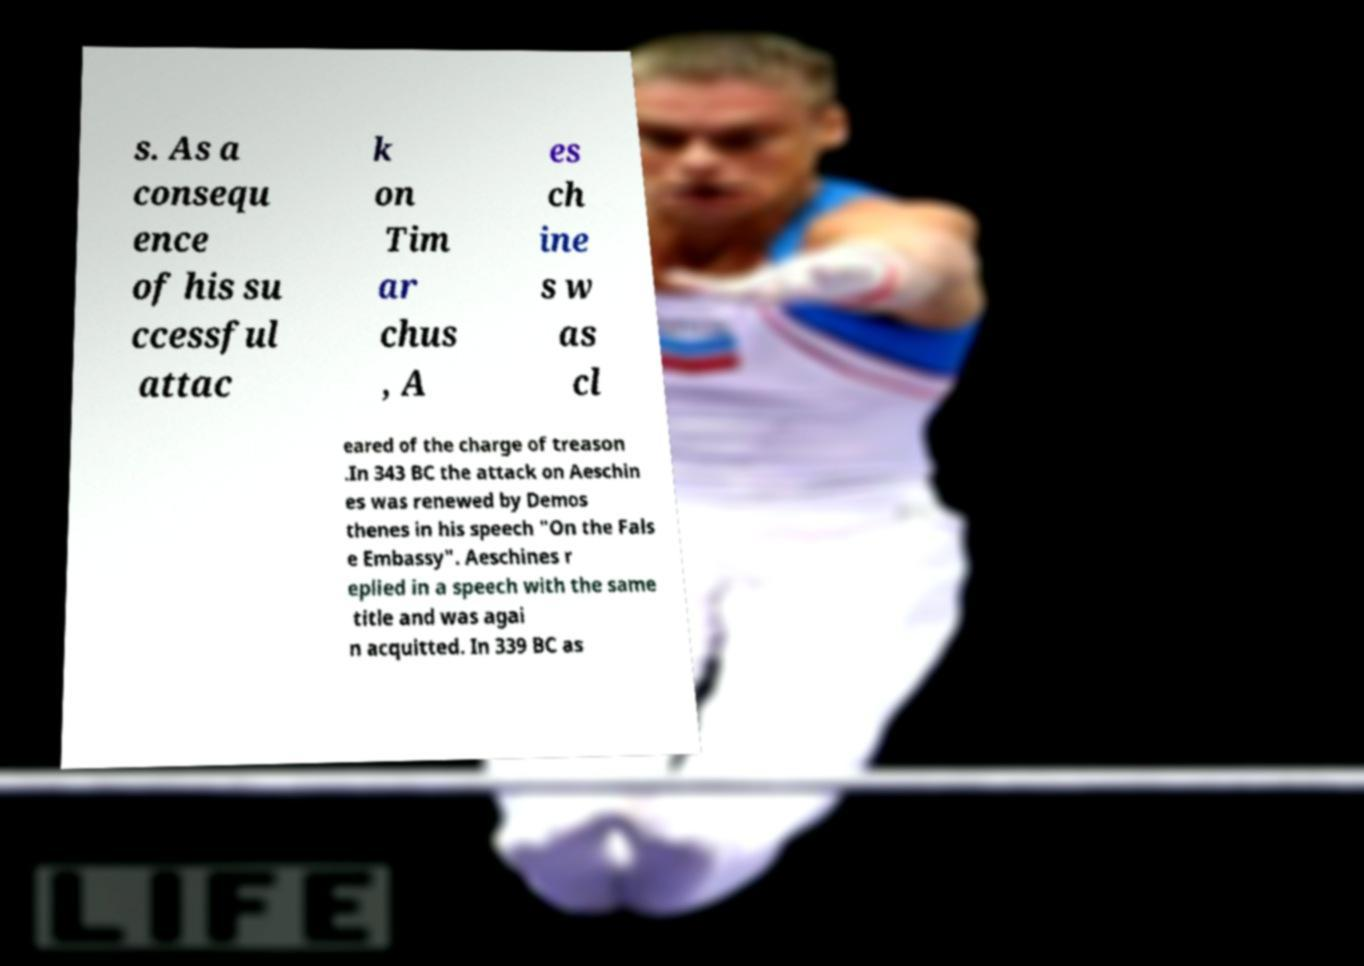Can you accurately transcribe the text from the provided image for me? s. As a consequ ence of his su ccessful attac k on Tim ar chus , A es ch ine s w as cl eared of the charge of treason .In 343 BC the attack on Aeschin es was renewed by Demos thenes in his speech "On the Fals e Embassy". Aeschines r eplied in a speech with the same title and was agai n acquitted. In 339 BC as 